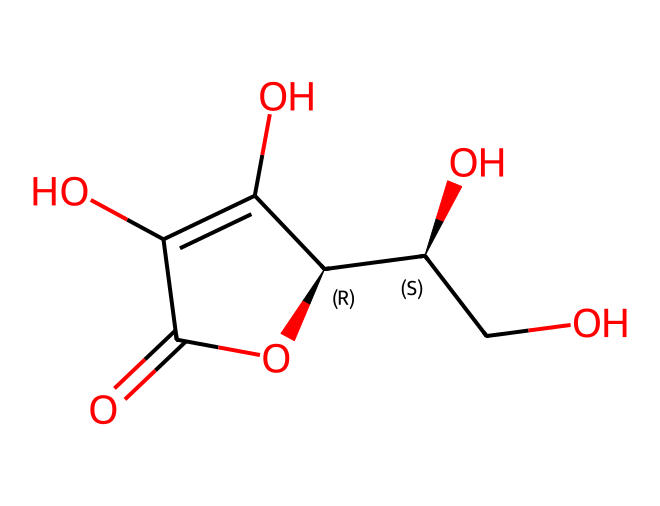How many carbon atoms are in ascorbic acid? Counting the carbon atoms in the SMILES representation, we see that there are 6 carbon atoms connected within the molecular structure.
Answer: 6 What functional groups are present in ascorbic acid? By analyzing the SMILES, we can identify hydroxyl (-OH) groups and a carbonyl (C=O) group, indicating the presence of alcohols and a ketone.
Answer: hydroxyl, carbonyl What is the molecular formula of ascorbic acid? To determine the molecular formula, we count the individual atoms represented in the SMILES: C, H, and O. For ascorbic acid, the formula is C6H8O6.
Answer: C6H8O6 What is the primary antioxidant feature of ascorbic acid? The presence of multiple hydroxyl groups contributes to its effectiveness as an antioxidant by donating electrons to neutralize free radicals.
Answer: electron donor How does ascorbic acid contribute to cognitive enhancement? As an antioxidant, it helps protect neural cells from oxidative stress, which can improve overall brain function and cognitive performance.
Answer: oxidative stress protection What is the relationship between ascorbic acid and functional beverages? Ascorbic acid is often added to functional beverages for its antioxidant properties, which are marketed to enhance cognitive function and overall health.
Answer: antioxidant properties How many oxygen atoms are there in ascorbic acid? Identifying the oxygen atoms in the SMILES structure, we find there are 6 oxygen atoms present within the molecule.
Answer: 6 